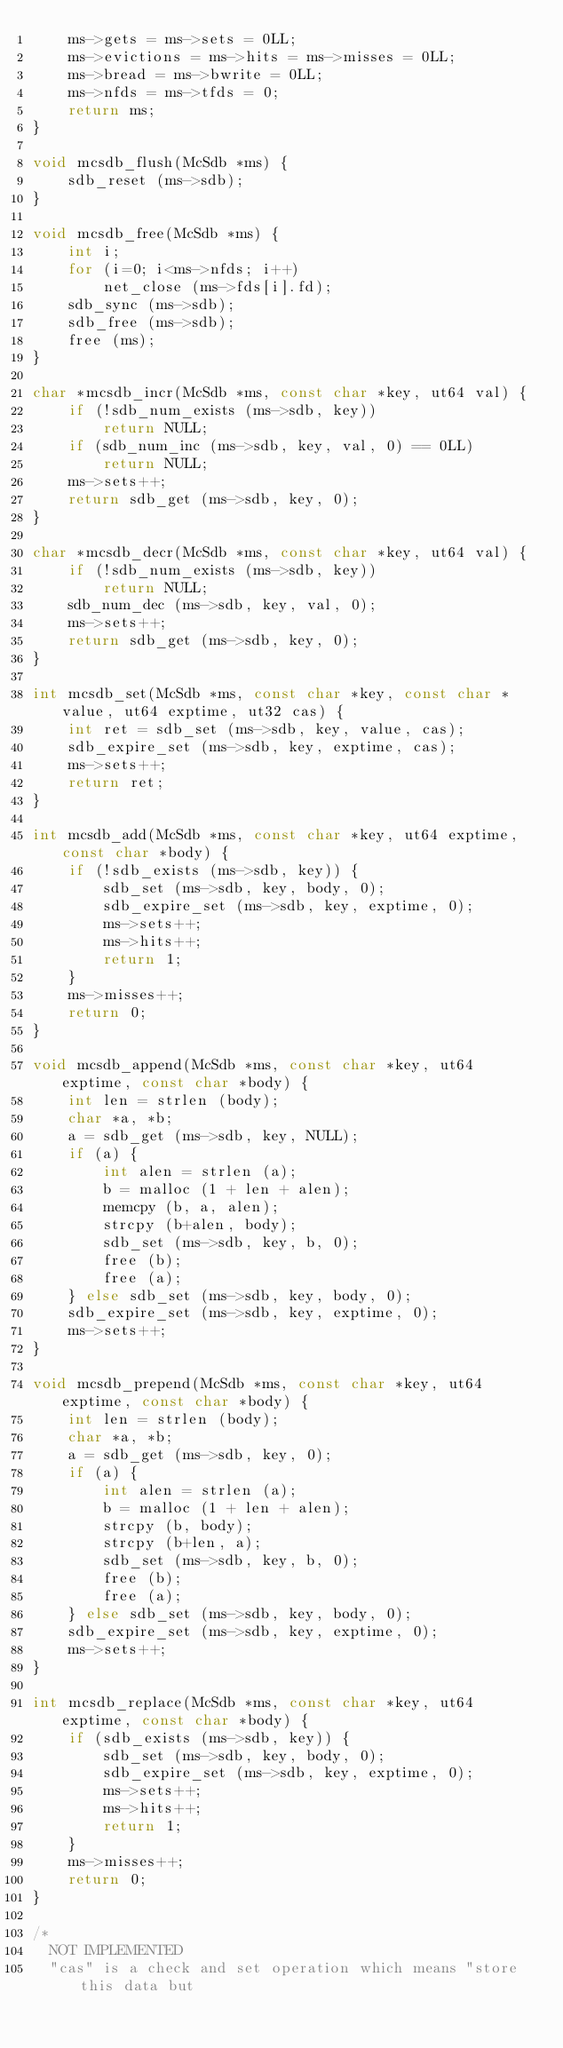<code> <loc_0><loc_0><loc_500><loc_500><_C_>	ms->gets = ms->sets = 0LL;
	ms->evictions = ms->hits = ms->misses = 0LL;
	ms->bread = ms->bwrite = 0LL;
	ms->nfds = ms->tfds = 0;
	return ms;
}

void mcsdb_flush(McSdb *ms) {
	sdb_reset (ms->sdb);
}

void mcsdb_free(McSdb *ms) {
	int i;
	for (i=0; i<ms->nfds; i++)
		net_close (ms->fds[i].fd);
	sdb_sync (ms->sdb);
	sdb_free (ms->sdb);
	free (ms);
}

char *mcsdb_incr(McSdb *ms, const char *key, ut64 val) {
	if (!sdb_num_exists (ms->sdb, key))
		return NULL;
	if (sdb_num_inc (ms->sdb, key, val, 0) == 0LL)
		return NULL;
	ms->sets++;
	return sdb_get (ms->sdb, key, 0);
}

char *mcsdb_decr(McSdb *ms, const char *key, ut64 val) {
	if (!sdb_num_exists (ms->sdb, key))
		return NULL;
	sdb_num_dec (ms->sdb, key, val, 0);
	ms->sets++;
	return sdb_get (ms->sdb, key, 0);
}

int mcsdb_set(McSdb *ms, const char *key, const char *value, ut64 exptime, ut32 cas) {
	int ret = sdb_set (ms->sdb, key, value, cas);
	sdb_expire_set (ms->sdb, key, exptime, cas);
	ms->sets++;
	return ret;
}

int mcsdb_add(McSdb *ms, const char *key, ut64 exptime, const char *body) {
	if (!sdb_exists (ms->sdb, key)) {
		sdb_set (ms->sdb, key, body, 0);
		sdb_expire_set (ms->sdb, key, exptime, 0);
		ms->sets++;
		ms->hits++;
		return 1;
	}
	ms->misses++;
	return 0;
}

void mcsdb_append(McSdb *ms, const char *key, ut64 exptime, const char *body) {
	int len = strlen (body);
	char *a, *b;
	a = sdb_get (ms->sdb, key, NULL);
	if (a) {
		int alen = strlen (a);
		b = malloc (1 + len + alen);
		memcpy (b, a, alen);
		strcpy (b+alen, body);
		sdb_set (ms->sdb, key, b, 0);
		free (b);
		free (a);
	} else sdb_set (ms->sdb, key, body, 0);
	sdb_expire_set (ms->sdb, key, exptime, 0);
	ms->sets++;
}

void mcsdb_prepend(McSdb *ms, const char *key, ut64 exptime, const char *body) {
	int len = strlen (body);
	char *a, *b;
	a = sdb_get (ms->sdb, key, 0);
	if (a) {
		int alen = strlen (a);
		b = malloc (1 + len + alen);
		strcpy (b, body);
		strcpy (b+len, a);
		sdb_set (ms->sdb, key, b, 0);
		free (b);
		free (a);
	} else sdb_set (ms->sdb, key, body, 0);
	sdb_expire_set (ms->sdb, key, exptime, 0);
	ms->sets++;
}

int mcsdb_replace(McSdb *ms, const char *key, ut64 exptime, const char *body) {
	if (sdb_exists (ms->sdb, key)) {
		sdb_set (ms->sdb, key, body, 0);
		sdb_expire_set (ms->sdb, key, exptime, 0);
		ms->sets++;
		ms->hits++;
		return 1;
	}
	ms->misses++;
	return 0;
}

/*
  NOT IMPLEMENTED
  "cas" is a check and set operation which means "store this data but</code> 